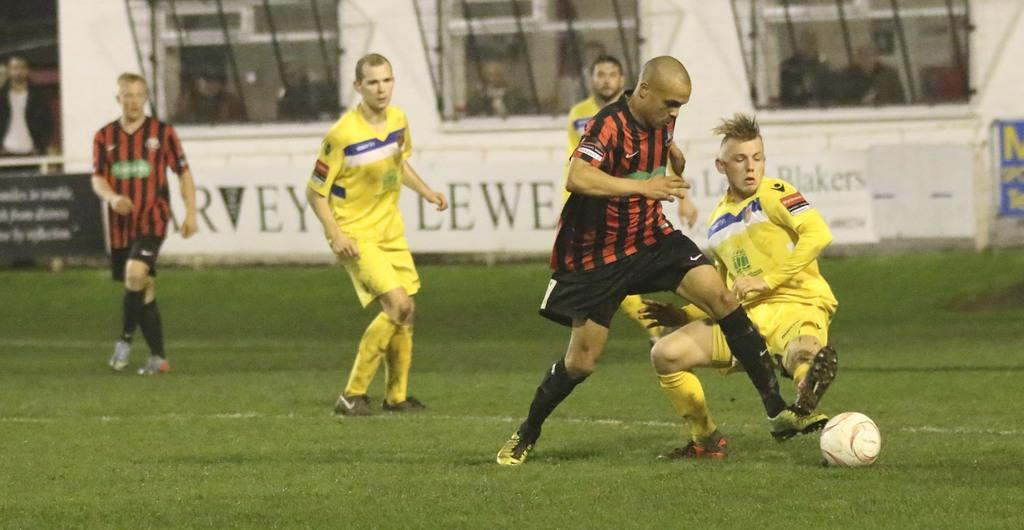<image>
Create a compact narrative representing the image presented. Players playing soccer on a field with the letter w on a sign behind them. 